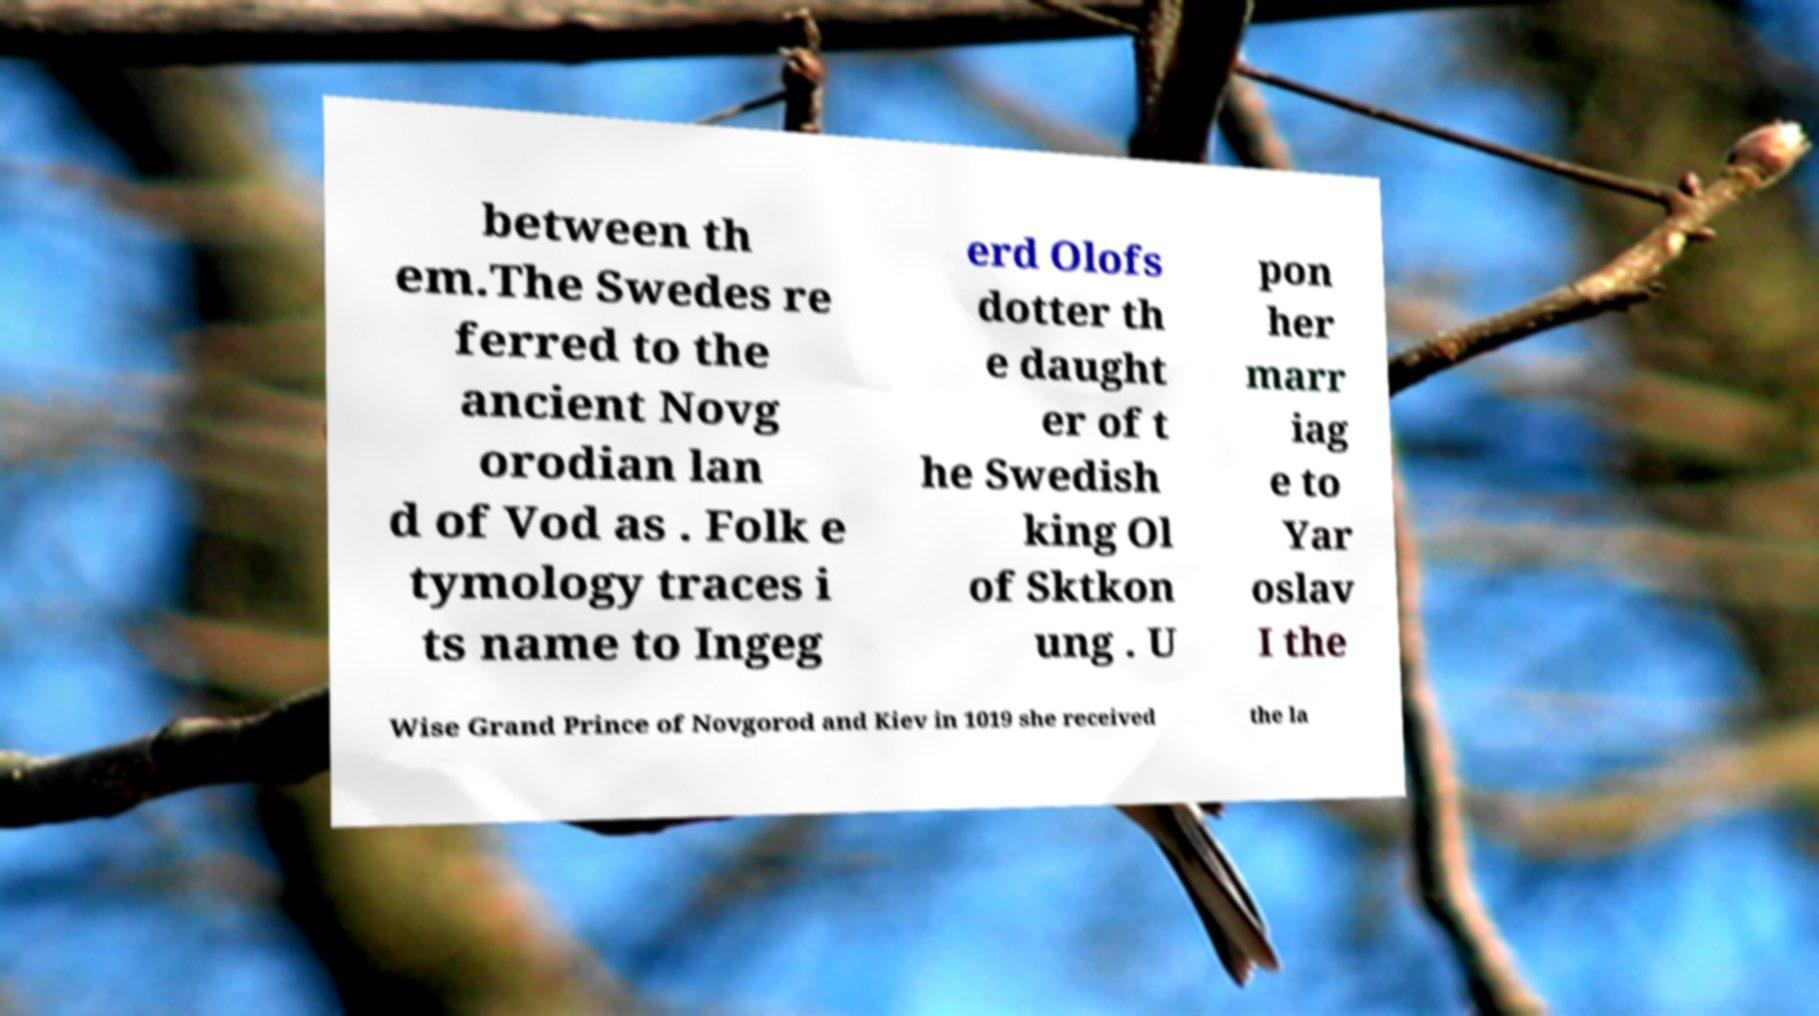For documentation purposes, I need the text within this image transcribed. Could you provide that? between th em.The Swedes re ferred to the ancient Novg orodian lan d of Vod as . Folk e tymology traces i ts name to Ingeg erd Olofs dotter th e daught er of t he Swedish king Ol of Sktkon ung . U pon her marr iag e to Yar oslav I the Wise Grand Prince of Novgorod and Kiev in 1019 she received the la 